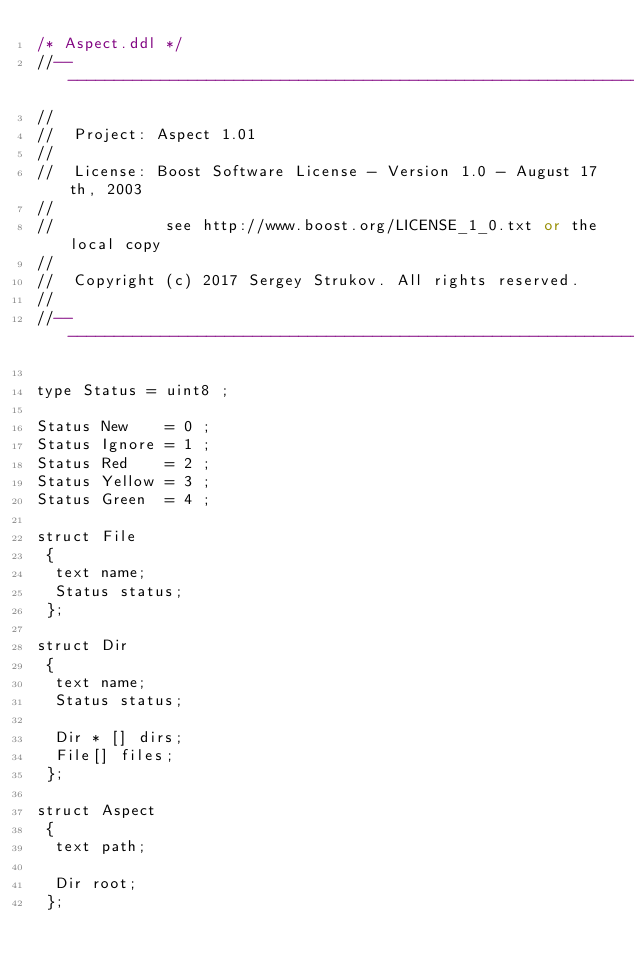<code> <loc_0><loc_0><loc_500><loc_500><_SQL_>/* Aspect.ddl */
//----------------------------------------------------------------------------------------
//
//  Project: Aspect 1.01
//
//  License: Boost Software License - Version 1.0 - August 17th, 2003
//
//            see http://www.boost.org/LICENSE_1_0.txt or the local copy
//
//  Copyright (c) 2017 Sergey Strukov. All rights reserved.
//
//----------------------------------------------------------------------------------------

type Status = uint8 ;

Status New    = 0 ; 
Status Ignore = 1 ;
Status Red    = 2 ;
Status Yellow = 3 ;
Status Green  = 4 ;

struct File
 {
  text name;
  Status status;  
 };

struct Dir
 {
  text name;
  Status status; 
  
  Dir * [] dirs;
  File[] files;
 };

struct Aspect
 {
  text path;
  
  Dir root;  
 };
 
</code> 